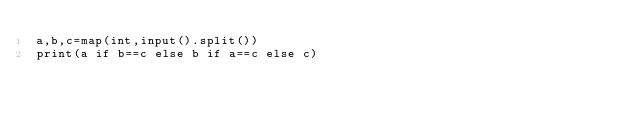<code> <loc_0><loc_0><loc_500><loc_500><_Python_>a,b,c=map(int,input().split())
print(a if b==c else b if a==c else c)
</code> 